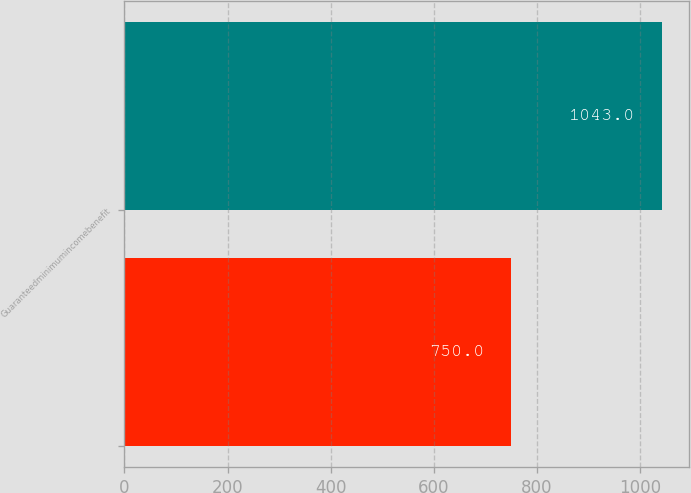<chart> <loc_0><loc_0><loc_500><loc_500><bar_chart><ecel><fcel>Guaranteedminimumincomebenefit<nl><fcel>750<fcel>1043<nl></chart> 